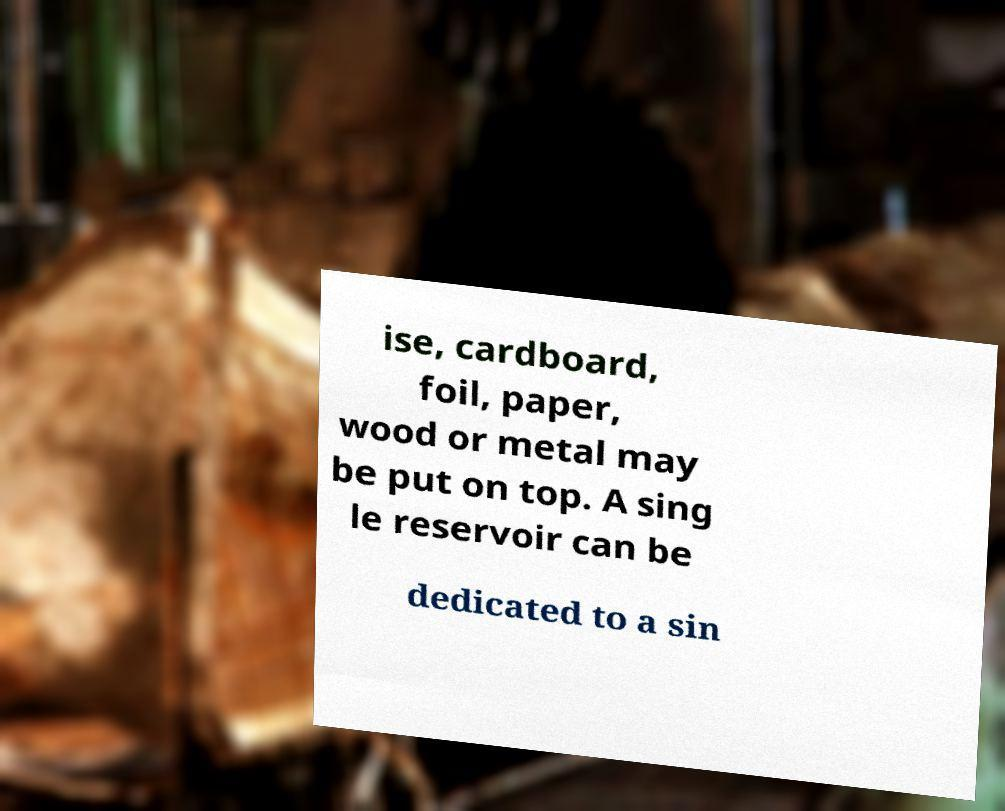Please identify and transcribe the text found in this image. ise, cardboard, foil, paper, wood or metal may be put on top. A sing le reservoir can be dedicated to a sin 